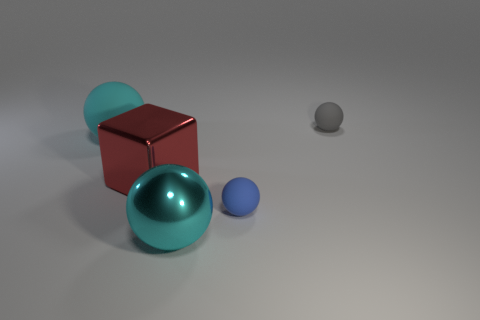Is the ball to the left of the large cyan metal ball made of the same material as the blue thing?
Your response must be concise. Yes. What number of blue matte objects have the same shape as the gray object?
Keep it short and to the point. 1. What number of tiny objects are either cyan metallic cubes or blue spheres?
Your response must be concise. 1. Is the color of the tiny sphere that is in front of the big matte ball the same as the cube?
Provide a short and direct response. No. There is a big object on the right side of the big red object; is its color the same as the tiny matte ball that is in front of the gray rubber thing?
Your answer should be compact. No. Is there a purple sphere that has the same material as the big red cube?
Your answer should be compact. No. What number of red objects are rubber things or spheres?
Offer a very short reply. 0. Are there more gray spheres right of the gray rubber object than small red rubber balls?
Offer a very short reply. No. Does the blue ball have the same size as the red thing?
Your response must be concise. No. What is the color of the tiny sphere that is the same material as the small blue thing?
Your answer should be very brief. Gray. 